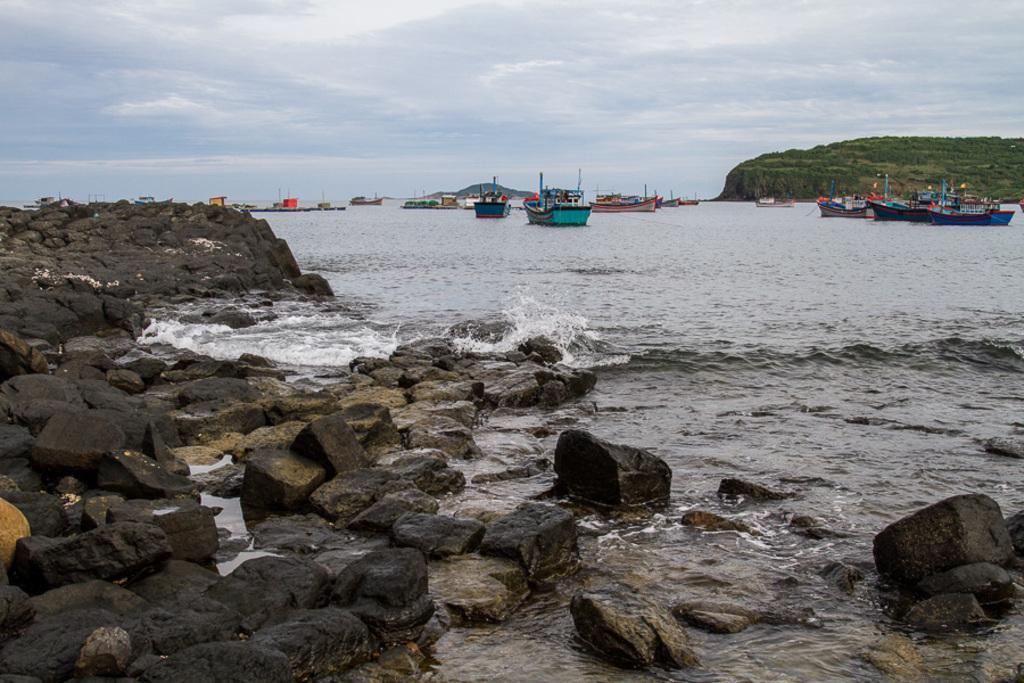Can you describe this image briefly? In this picture, there are boats sailing in the water. At the bottom of the picture, we see rocks and stones. This water might be in the sea. In the right top of the picture, there are trees. At the top of the picture, we see the sky. 